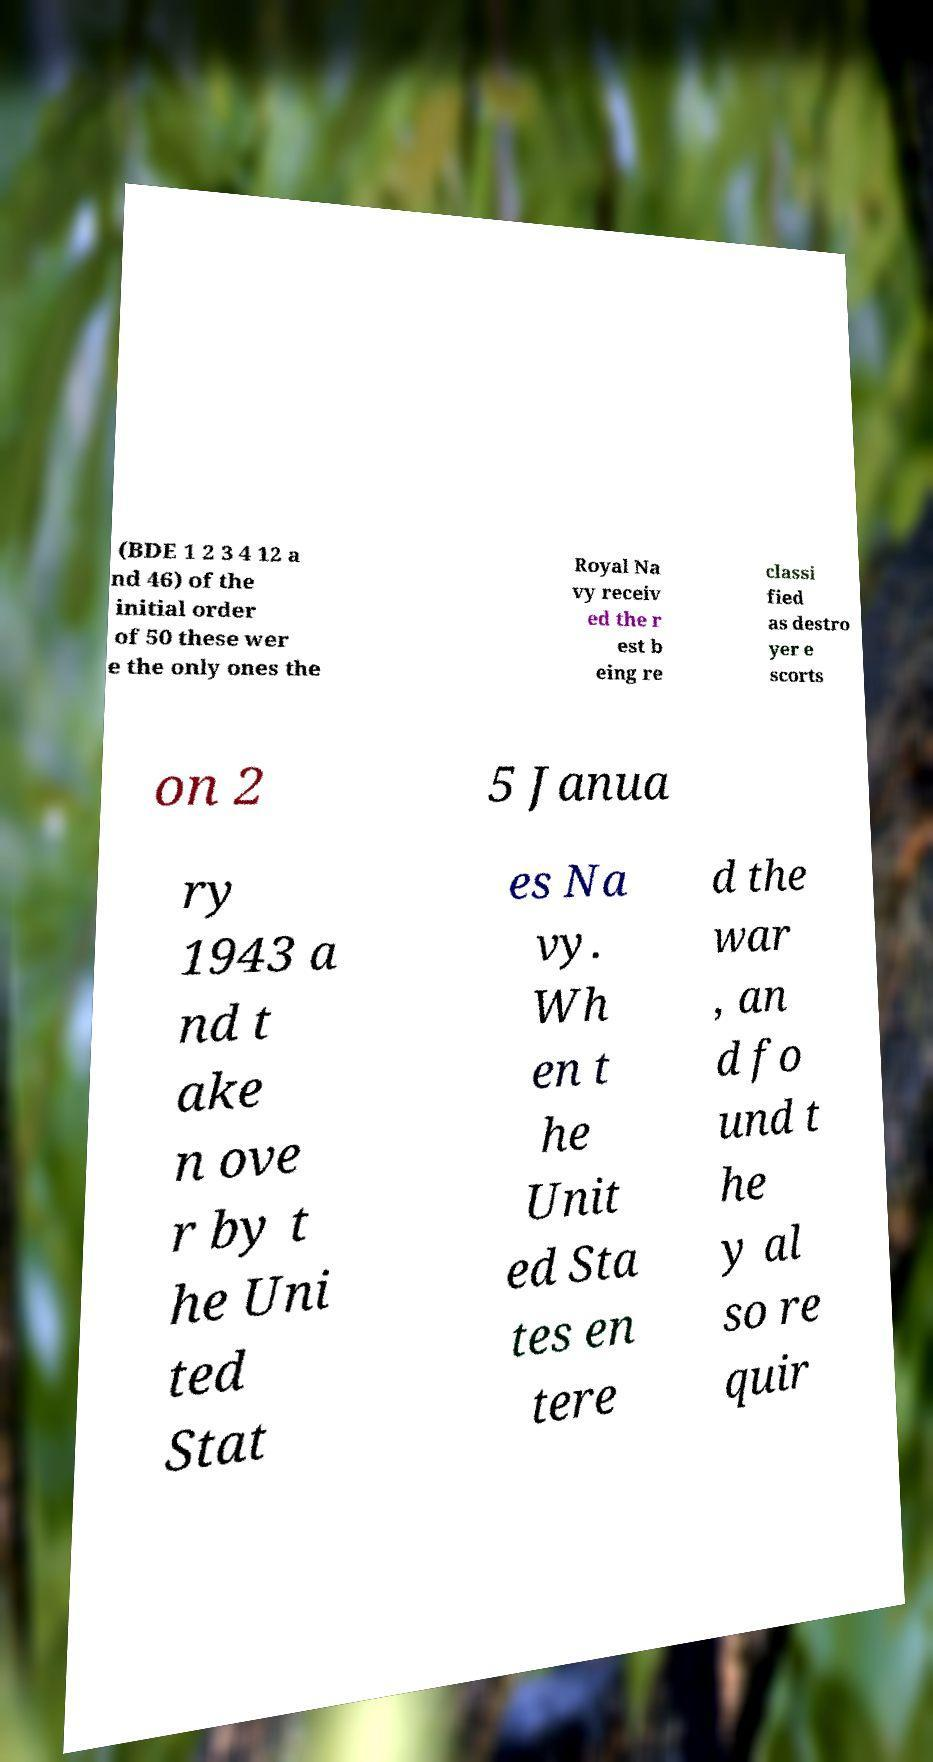Please identify and transcribe the text found in this image. (BDE 1 2 3 4 12 a nd 46) of the initial order of 50 these wer e the only ones the Royal Na vy receiv ed the r est b eing re classi fied as destro yer e scorts on 2 5 Janua ry 1943 a nd t ake n ove r by t he Uni ted Stat es Na vy. Wh en t he Unit ed Sta tes en tere d the war , an d fo und t he y al so re quir 